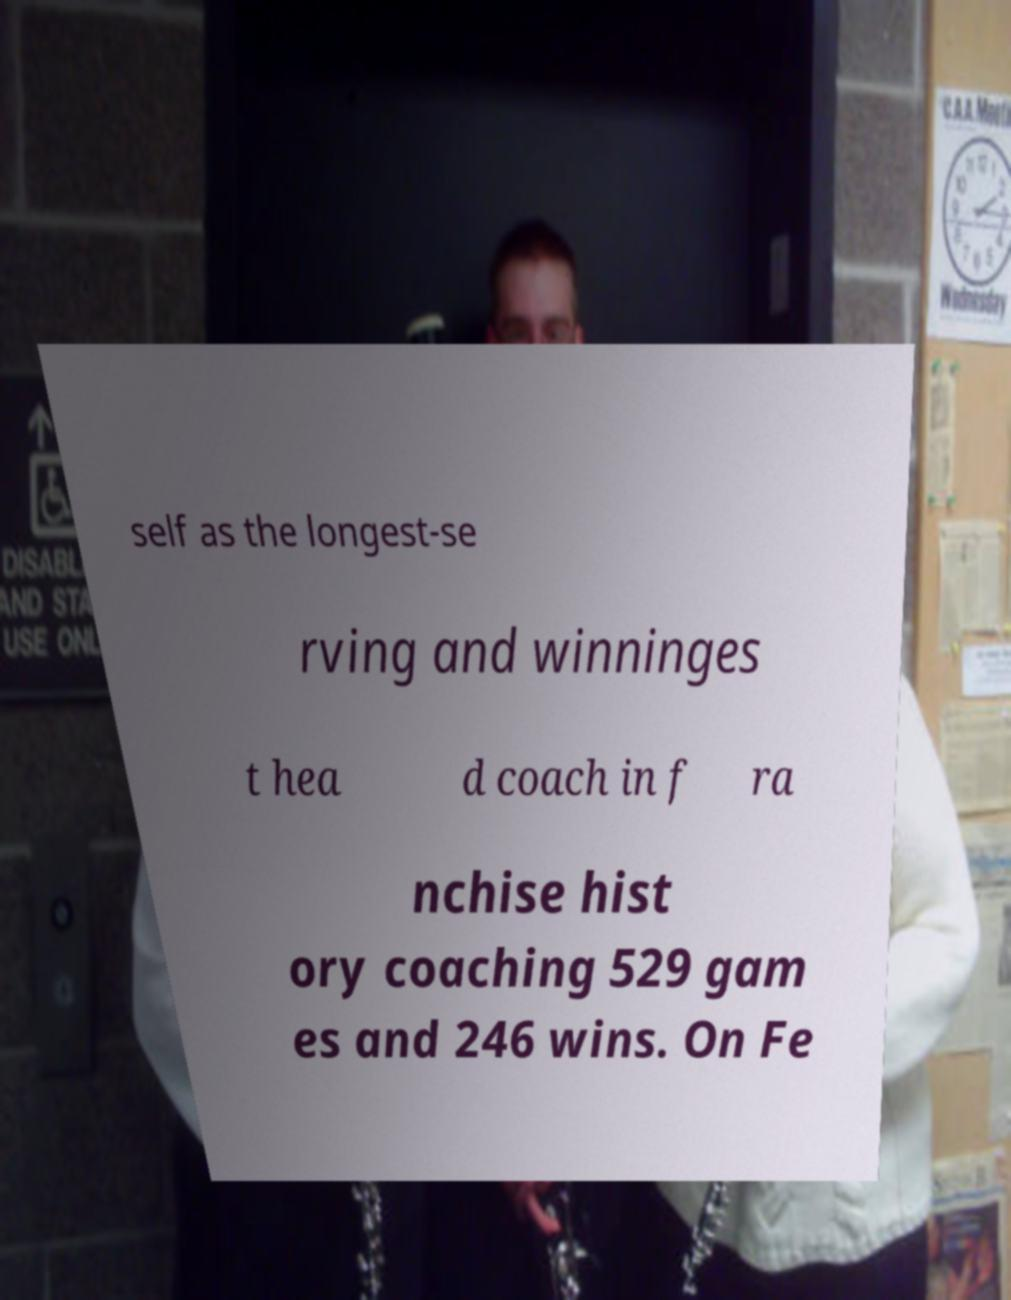For documentation purposes, I need the text within this image transcribed. Could you provide that? self as the longest-se rving and winninges t hea d coach in f ra nchise hist ory coaching 529 gam es and 246 wins. On Fe 